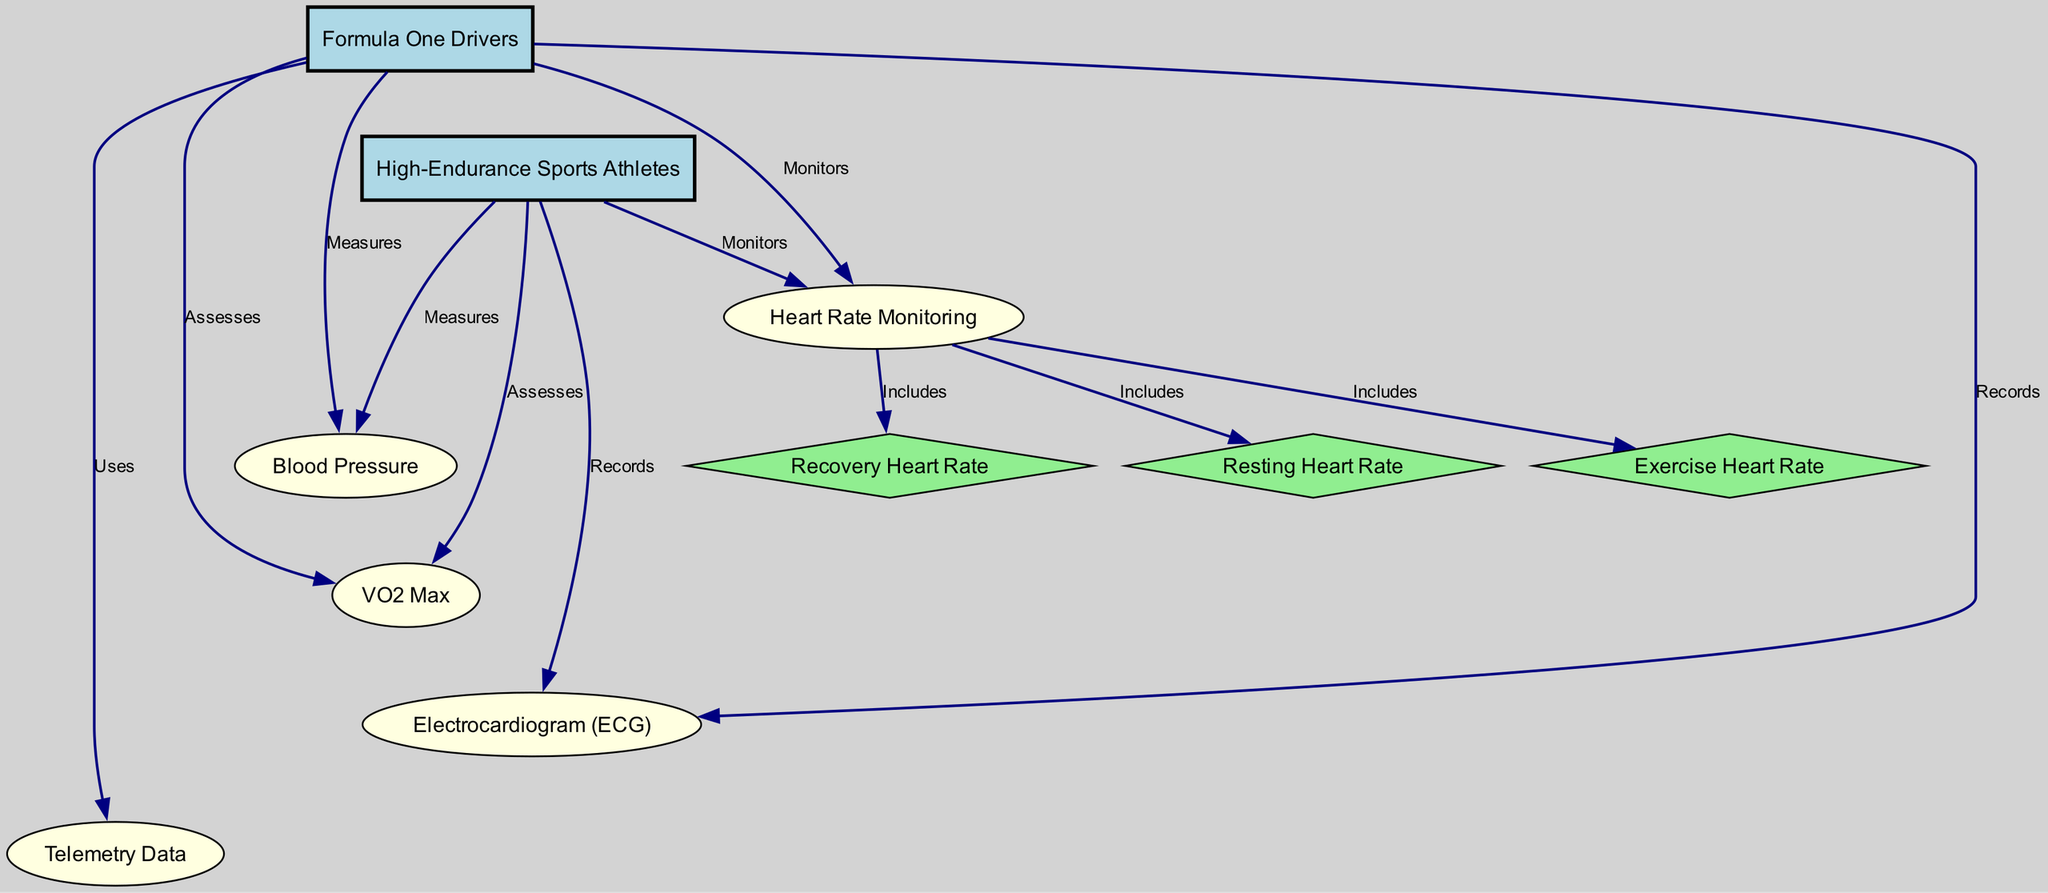What is the main focus of the diagram? The title of the diagram explicitly states that it focuses on "Cardiovascular Health Monitoring in Athletes: Comparing Formula One Drivers with Other High-Endurance Sports Athletes." This indicates that the central theme is about monitoring cardiovascular health in these specific groups of athletes.
Answer: Cardiovascular Health Monitoring How many nodes are present in the diagram? The diagram lists a total of ten nodes, including both the types of athletes and the various measurements or monitoring methods. Counting each node inside the diagram confirms this number.
Answer: Ten What type of data do Formula One Drivers use according to the diagram? According to the edges originating from the Formula One Drivers node, they utilize "Telemetry Data" as part of their cardiovascular health monitoring techniques. This is demonstrated in the relationship between the F1 Drivers node and the Telemetry node, which is pointed out by the label "Uses."
Answer: Telemetry Data Which monitoring method includes Exercise Heart Rate? The contour "Heart Rate Monitoring" encompasses three specific aspects: Resting Heart Rate, Exercise Heart Rate, and Recovery Heart Rate. Therefore, Exercise Heart Rate is included under this specific category, as indicated by the "Includes" relationships shown in the diagram.
Answer: Heart Rate Monitoring What is the relationship between Blood Pressure and Formula One Drivers? The diagram shows that Formula One Drivers "Measures" Blood Pressure, which establishes a direct relationship between those monitoring practices and the specific health parameter noted. Therefore, the role of blood pressure measurement is highlighted in relation to F1 drivers' health.
Answer: Measures How many types of athletes are explicitly compared in the diagram? The diagram presents a comparison between two types of athletes: Formula One Drivers and High-Endurance Sports Athletes. These nodes are distinctly labeled in the graph, demonstrating a direct focus on these two categories.
Answer: Two What does VO2 Max refer to in the context of the diagram? VO2 Max is a method of cardiovascular health assessment for both Formula One Drivers and High-Endurance Sports Athletes, as highlighted in the diagram's edges. The label "Assesses" next to VO2 Max indicates its role in evaluating the athletes' cardiovascular performance.
Answer: A method of assessment Which node relates to both Resting Heart Rate and Recovery Heart Rate? The node that connects Resting Heart Rate and Recovery Heart Rate is "Heart Rate Monitoring". This type of monitoring encompasses the different heart rates as part of its functions, indicated by the relationships displayed in the diagram.
Answer: Heart Rate Monitoring How do both types of athletes relate to ECG? The diagram shows that both Formula One Drivers and High-Endurance Sports Athletes "Records" Electrocardiogram (ECG) data. This implies that ECG is a common method utilized for monitoring in both athlete groups, stressing its importance in assessing cardiovascular health for both.
Answer: Records 